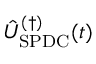Convert formula to latex. <formula><loc_0><loc_0><loc_500><loc_500>\hat { U } _ { S P D C } ^ { ( \dagger ) } ( t )</formula> 